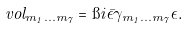Convert formula to latex. <formula><loc_0><loc_0><loc_500><loc_500>\ v o l _ { m _ { 1 } \dots m _ { 7 } } = \i i \bar { \epsilon } \gamma _ { m _ { 1 } \dots m _ { 7 } } \epsilon .</formula> 